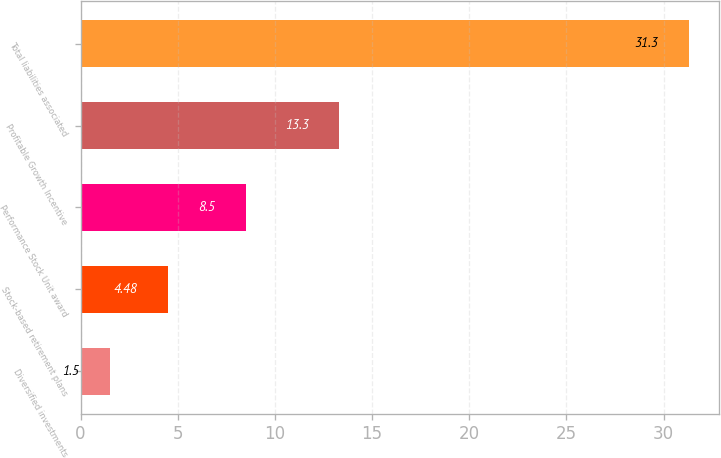Convert chart to OTSL. <chart><loc_0><loc_0><loc_500><loc_500><bar_chart><fcel>Diversified investments<fcel>Stock-based retirement plans<fcel>Performance Stock Unit award<fcel>Profitable Growth Incentive<fcel>Total liabilities associated<nl><fcel>1.5<fcel>4.48<fcel>8.5<fcel>13.3<fcel>31.3<nl></chart> 